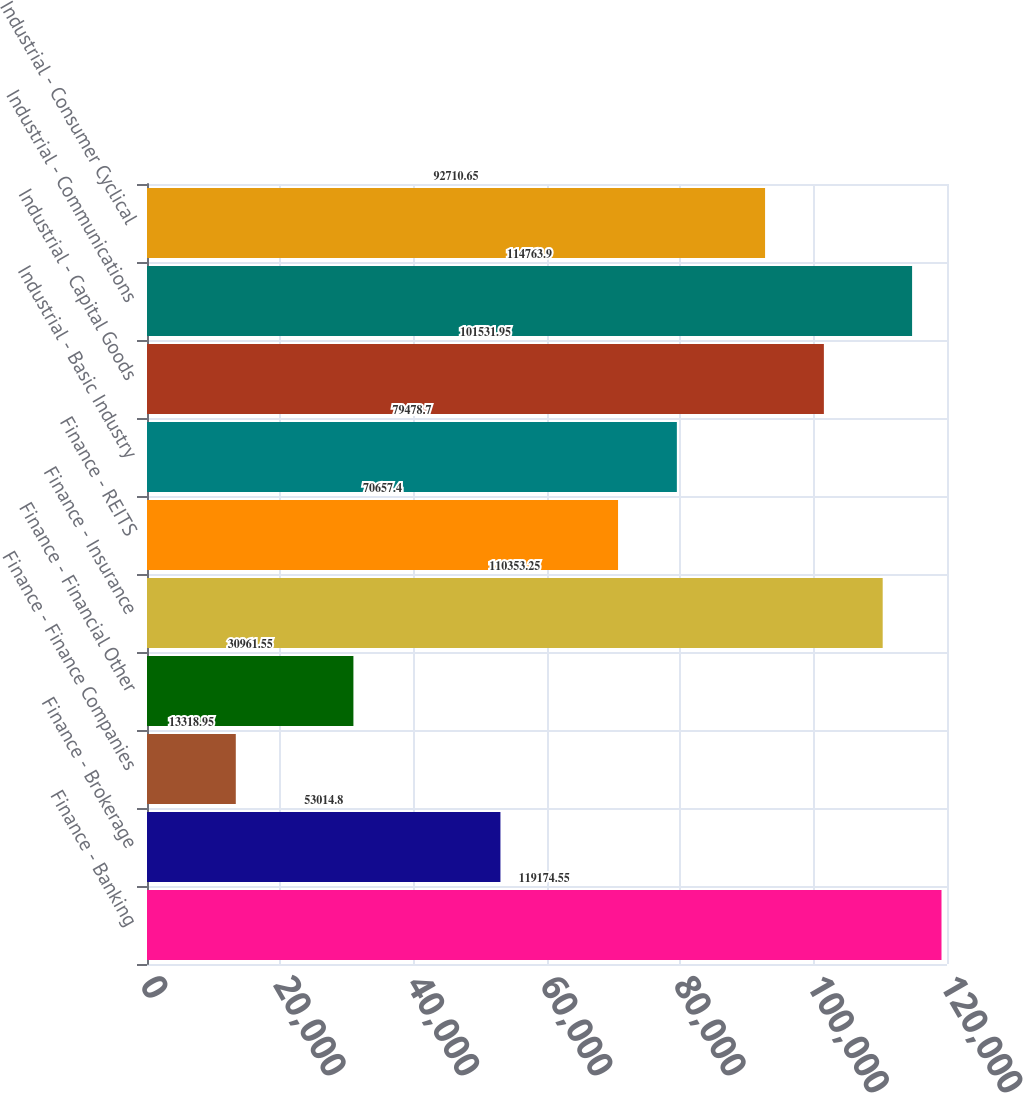Convert chart. <chart><loc_0><loc_0><loc_500><loc_500><bar_chart><fcel>Finance - Banking<fcel>Finance - Brokerage<fcel>Finance - Finance Companies<fcel>Finance - Financial Other<fcel>Finance - Insurance<fcel>Finance - REITS<fcel>Industrial - Basic Industry<fcel>Industrial - Capital Goods<fcel>Industrial - Communications<fcel>Industrial - Consumer Cyclical<nl><fcel>119175<fcel>53014.8<fcel>13319<fcel>30961.5<fcel>110353<fcel>70657.4<fcel>79478.7<fcel>101532<fcel>114764<fcel>92710.6<nl></chart> 